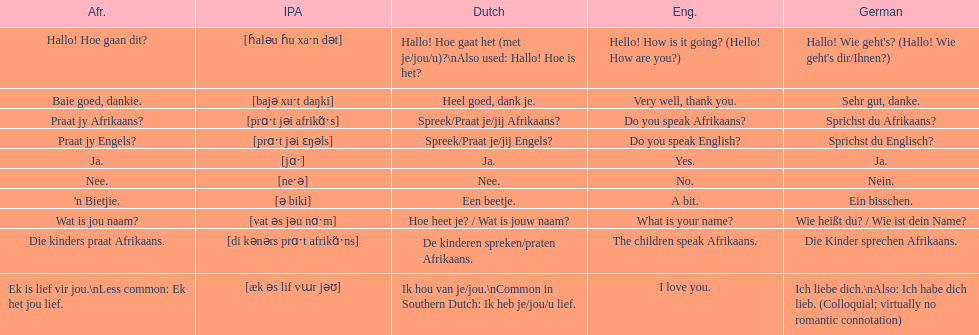Translate the following into english: 'n bietjie. A bit. 